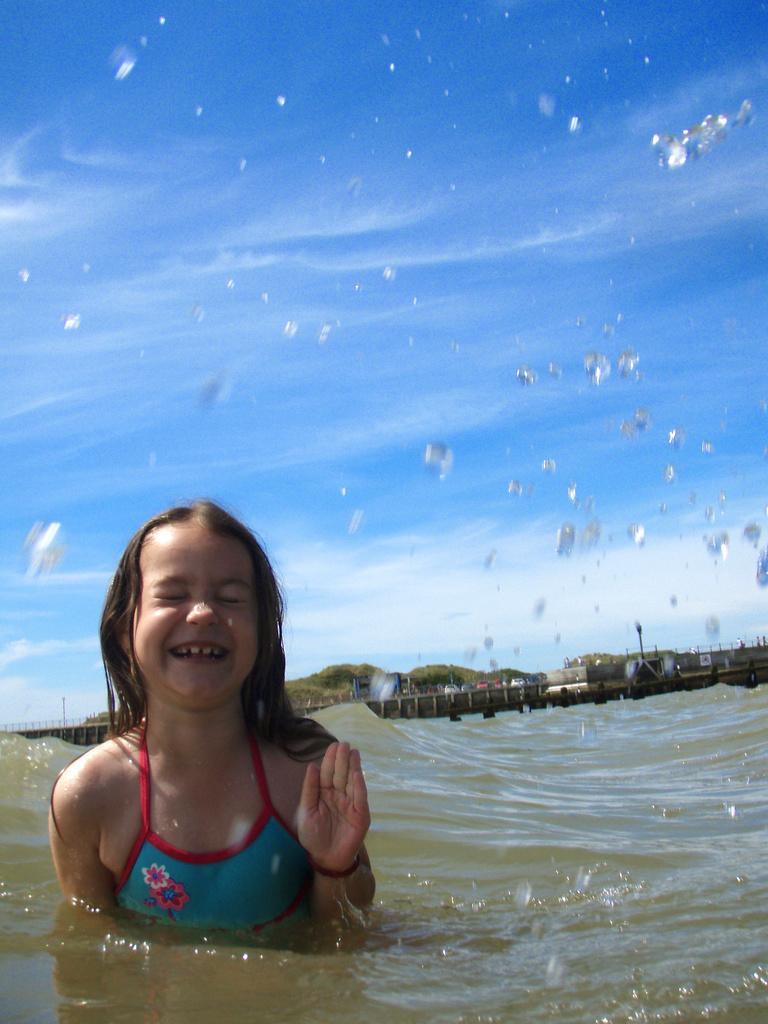Please provide a concise description of this image. In this image I can see a baby wearing a blue color dress visible on the lake ,at the top I can see the sky and I can see water bubbles visible in the middle , in the middle I can see trees. 